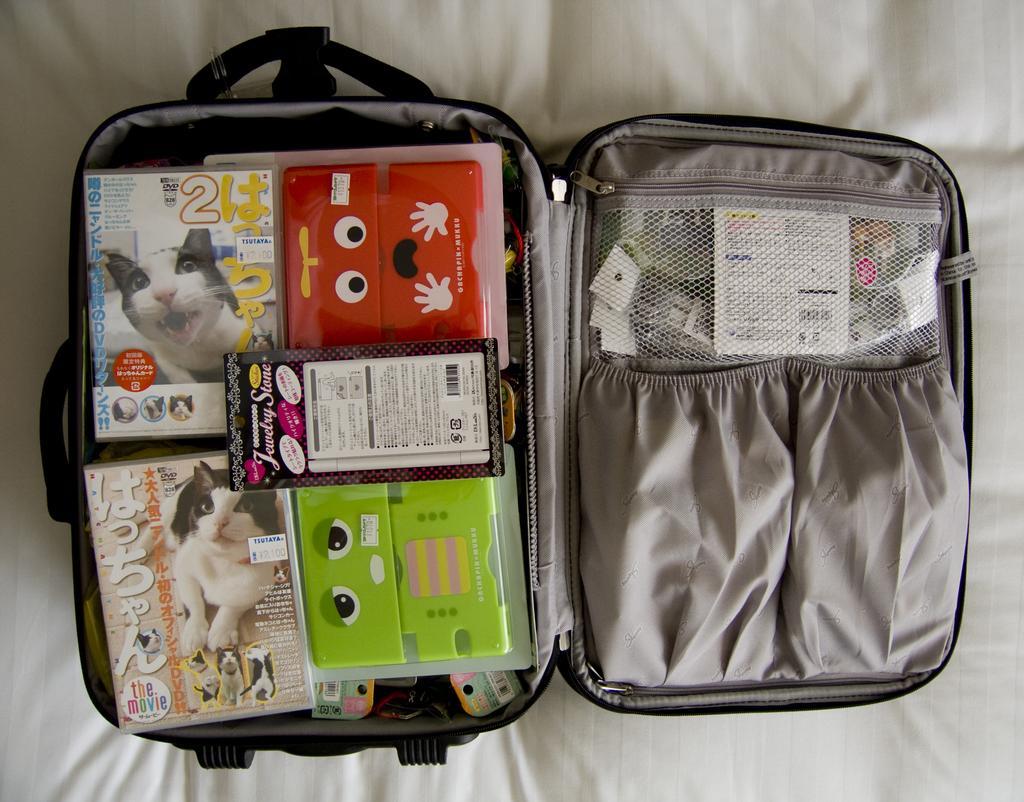In one or two sentences, can you explain what this image depicts? In this picture there is a suitcase with some objects kept in it and there is a handle to it, on to right there are some other objects placed in this pocket and it is placed on a white cloth and this suitcase has also some wheels 